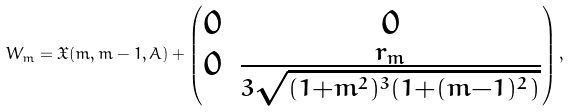<formula> <loc_0><loc_0><loc_500><loc_500>W _ { m } = \mathfrak { X } ( m , m - 1 , A ) + \begin{pmatrix} 0 & 0 \\ 0 & \frac { r _ { m } } { 3 \sqrt { ( 1 + m ^ { 2 } ) ^ { 3 } ( 1 + ( m - 1 ) ^ { 2 } ) } } \end{pmatrix} ,</formula> 